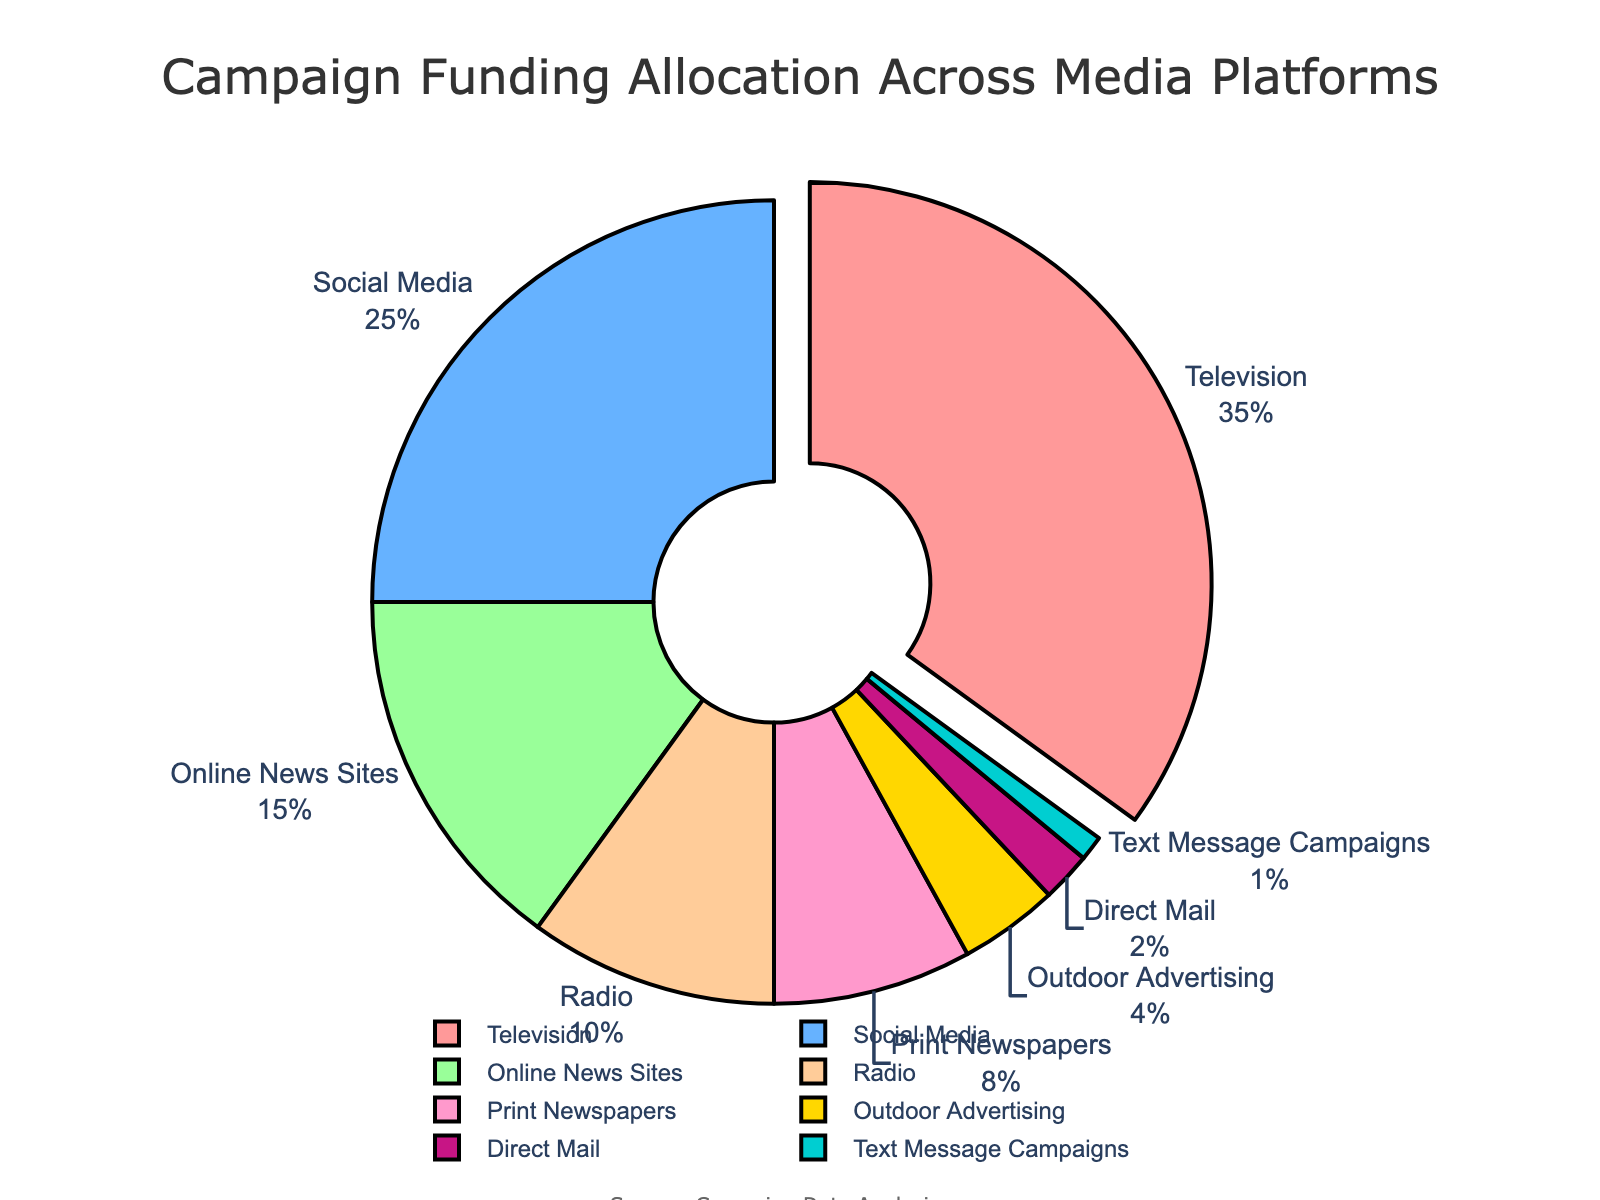What media platform receives the highest percentage of campaign funding? The platform with the highest percentage of the pie chart is the one with the largest slice and it is pulled out from the rest. This slice represents Television, which receives 35% of the funding.
Answer: Television How much more funding does Social Media receive compared to Print Newspapers? To find the difference in funding, subtract the percentage of Print Newspapers from the percentage of Social Media: 25% - 8% = 17%.
Answer: 17% Which media platform receives the lowest percentage of campaign funding? The smallest slice in the pie chart, which is Text Message Campaigns, receives 1% of the funding.
Answer: Text Message Campaigns What is the combined percentage of funding allocated to Online News Sites, Radio, and Print Newspapers? Add the percentages of the three platforms: Online News Sites (15%) + Radio (10%) + Print Newspapers (8%) = 33%.
Answer: 33% How does the funding allocated to Outdoor Advertising compare to that of Direct Mail? Compare the percentages directly: Outdoor Advertising (4%) is twice as much as Direct Mail (2%).
Answer: Outdoor Advertising is twice as much as Direct Mail What is the average percentage of funding allocated to Direct Mail, Text Message Campaigns, and Outdoor Advertising? To find the average, add the percentages and divide by the number of platforms: (2% + 1% + 4%) / 3 = 7% / 3 ≈ 2.33%.
Answer: 2.33% Which media platforms together make up half of the campaign funding? Add the percentages starting from the highest until you reach approximately 50%: Television (35%) + Social Media (25%) = 60%. Since 60% exceeds 50%, check if adding less is possible: Television (35%) alone is insufficient; Television + Social Media achieve this.
Answer: Television and Social Media What percentage of campaign funding is allocated to traditional media (Television, Radio, Print Newspapers)? Sum the percentages of the traditional media platforms: Television (35%) + Radio (10%) + Print Newspapers (8%) = 53%.
Answer: 53% Combine the percentage of funding allocated to the smallest three media platforms. How does it compare to the funding for Television? Sum the percentages of the three smallest platforms: Text Message Campaigns (1%) + Direct Mail (2%) + Outdoor Advertising (4%) = 7%. Then, compare it to Television's 35%. 7% is much less than 35%.
Answer: The combined percentage of the smallest three platforms is much less than Television's percentage 